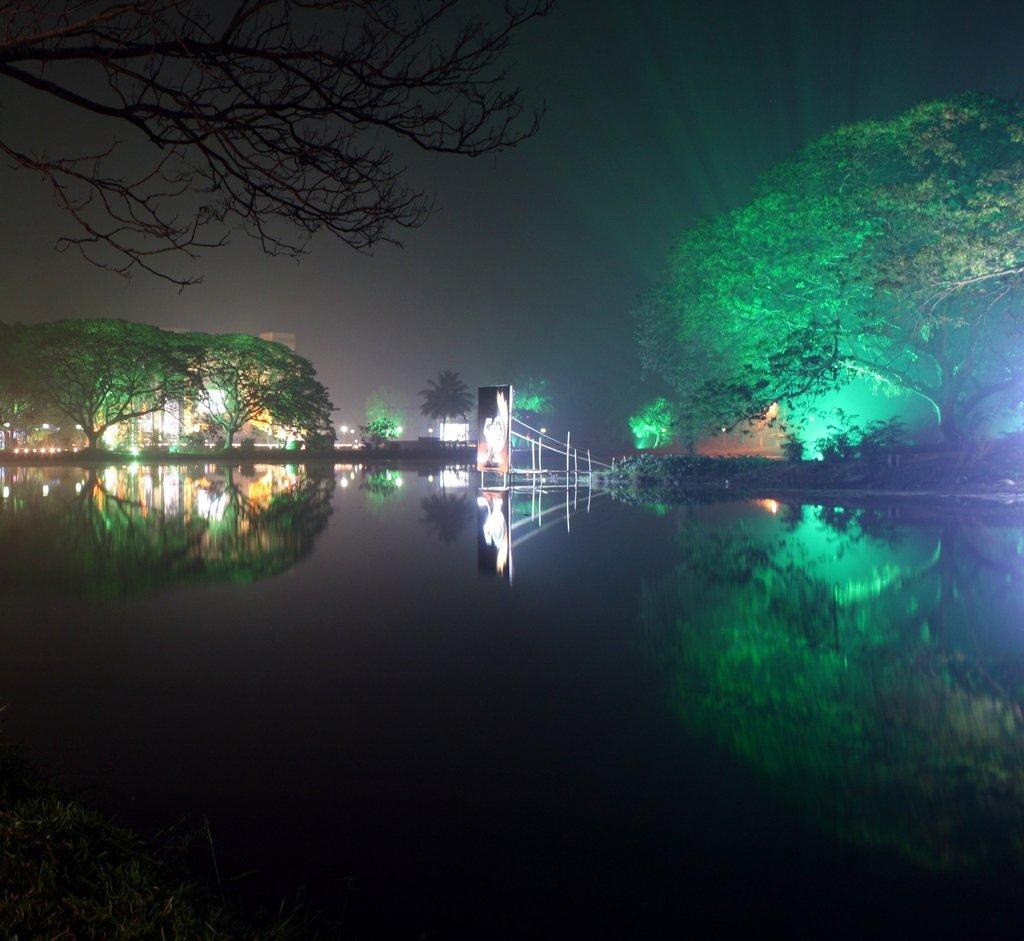What type of vegetation can be seen in the image? There are trees in the image. What structures are visible in the image? There are buildings in the image. What natural element is present in the image? Water is visible in the image. How does the water interact with the surrounding environment? The water reflects the trees and buildings in the image. What is visible in the background of the image? The sky is visible in the image. What type of yam is being used to stir the water in the image? There is no yam present in the image, and the water is not being stirred. How much sugar is dissolved in the water in the image? There is no sugar present in the image, and the water is not being used for dissolving anything. 